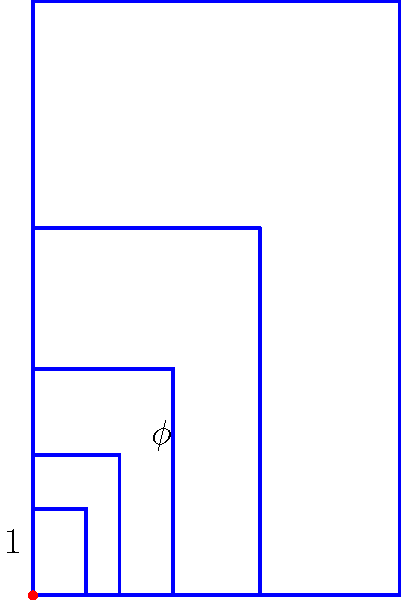In the Fibonacci spiral shown above, what is the approximate value of the ratio between consecutive terms, also known as the golden ratio ($\phi$), rounded to three decimal places? To find the golden ratio ($\phi$) in relation to the Fibonacci spiral, we can follow these steps:

1) The golden ratio is defined as $\phi = \frac{1 + \sqrt{5}}{2}$

2) Let's calculate this value:
   
   $\phi = \frac{1 + \sqrt{5}}{2}$
   
   $= \frac{1 + 2.236067977}{2}$ (using the square root of 5)
   
   $= \frac{3.236067977}{2}$
   
   $= 1.618033989$

3) Rounding to three decimal places:
   
   $1.618033989 \approx 1.618$

This ratio can be observed in the spiral. Each new square in the spiral has a side length that is the sum of the side lengths of the two preceding squares. The ratio of each new side length to the previous one approaches the golden ratio as the spiral expands.
Answer: $1.618$ 